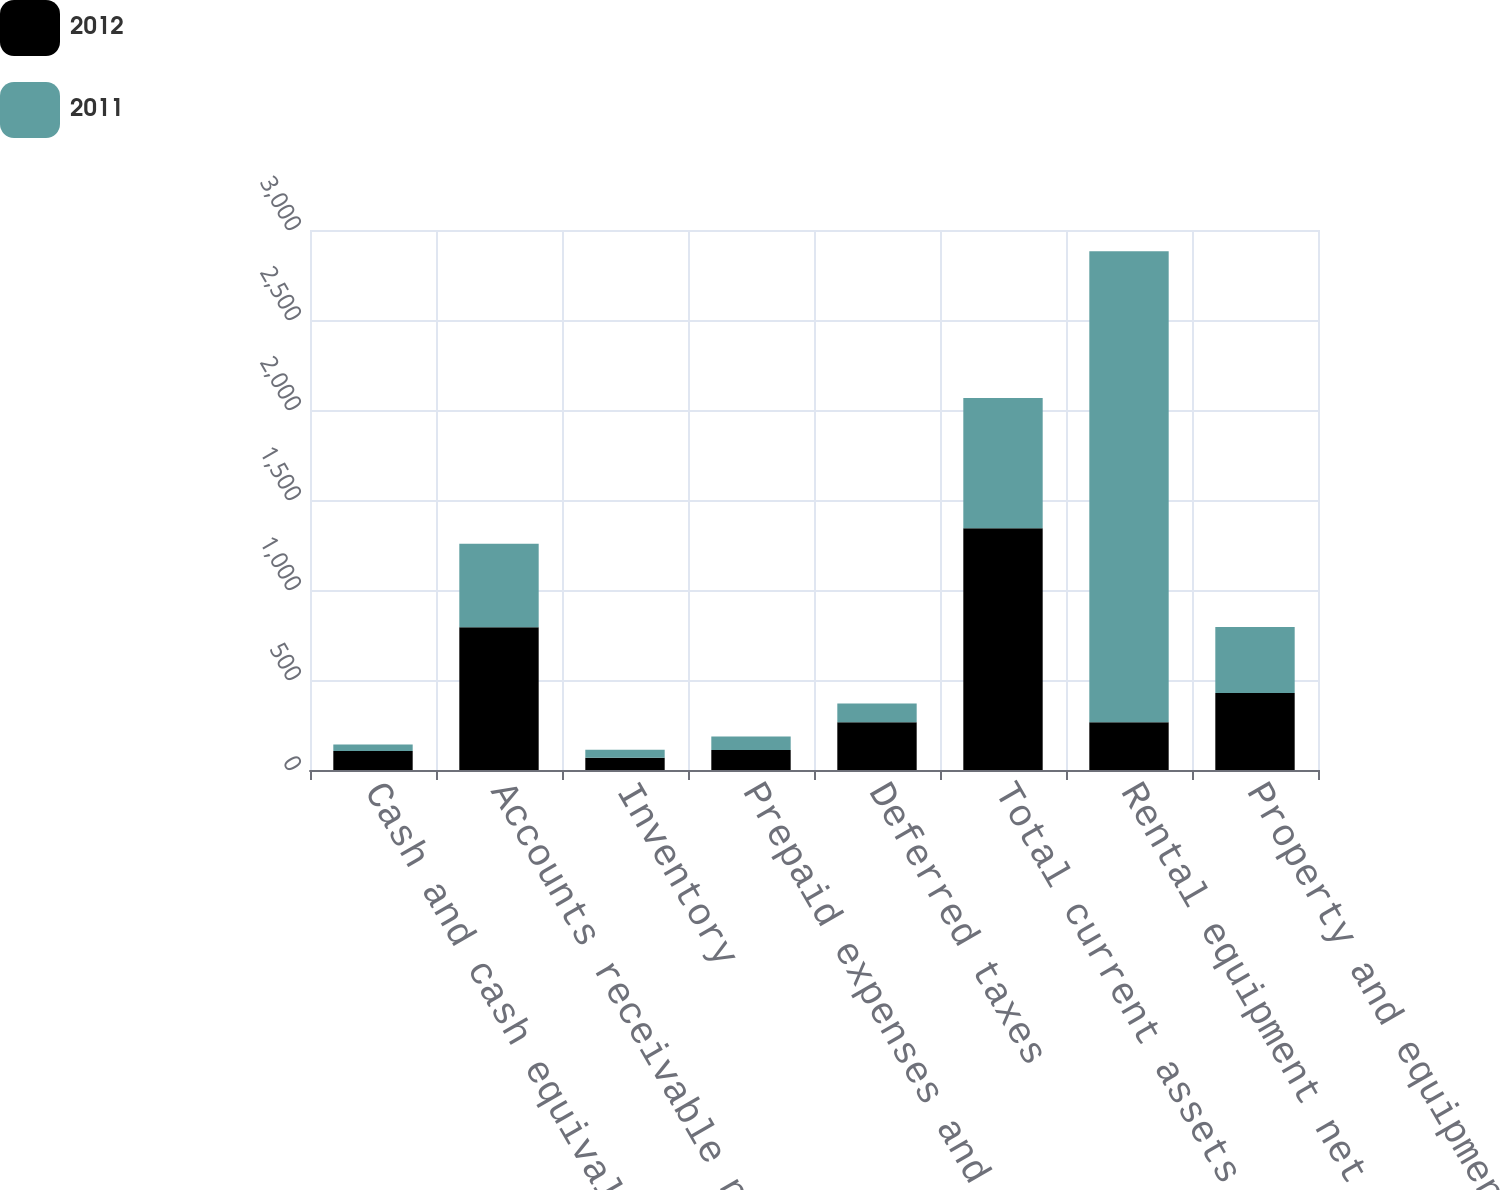Convert chart to OTSL. <chart><loc_0><loc_0><loc_500><loc_500><stacked_bar_chart><ecel><fcel>Cash and cash equivalents<fcel>Accounts receivable net of<fcel>Inventory<fcel>Prepaid expenses and other<fcel>Deferred taxes<fcel>Total current assets<fcel>Rental equipment net<fcel>Property and equipment net<nl><fcel>2012<fcel>106<fcel>793<fcel>68<fcel>111<fcel>265<fcel>1343<fcel>265<fcel>428<nl><fcel>2011<fcel>36<fcel>464<fcel>44<fcel>75<fcel>104<fcel>723<fcel>2617<fcel>366<nl></chart> 